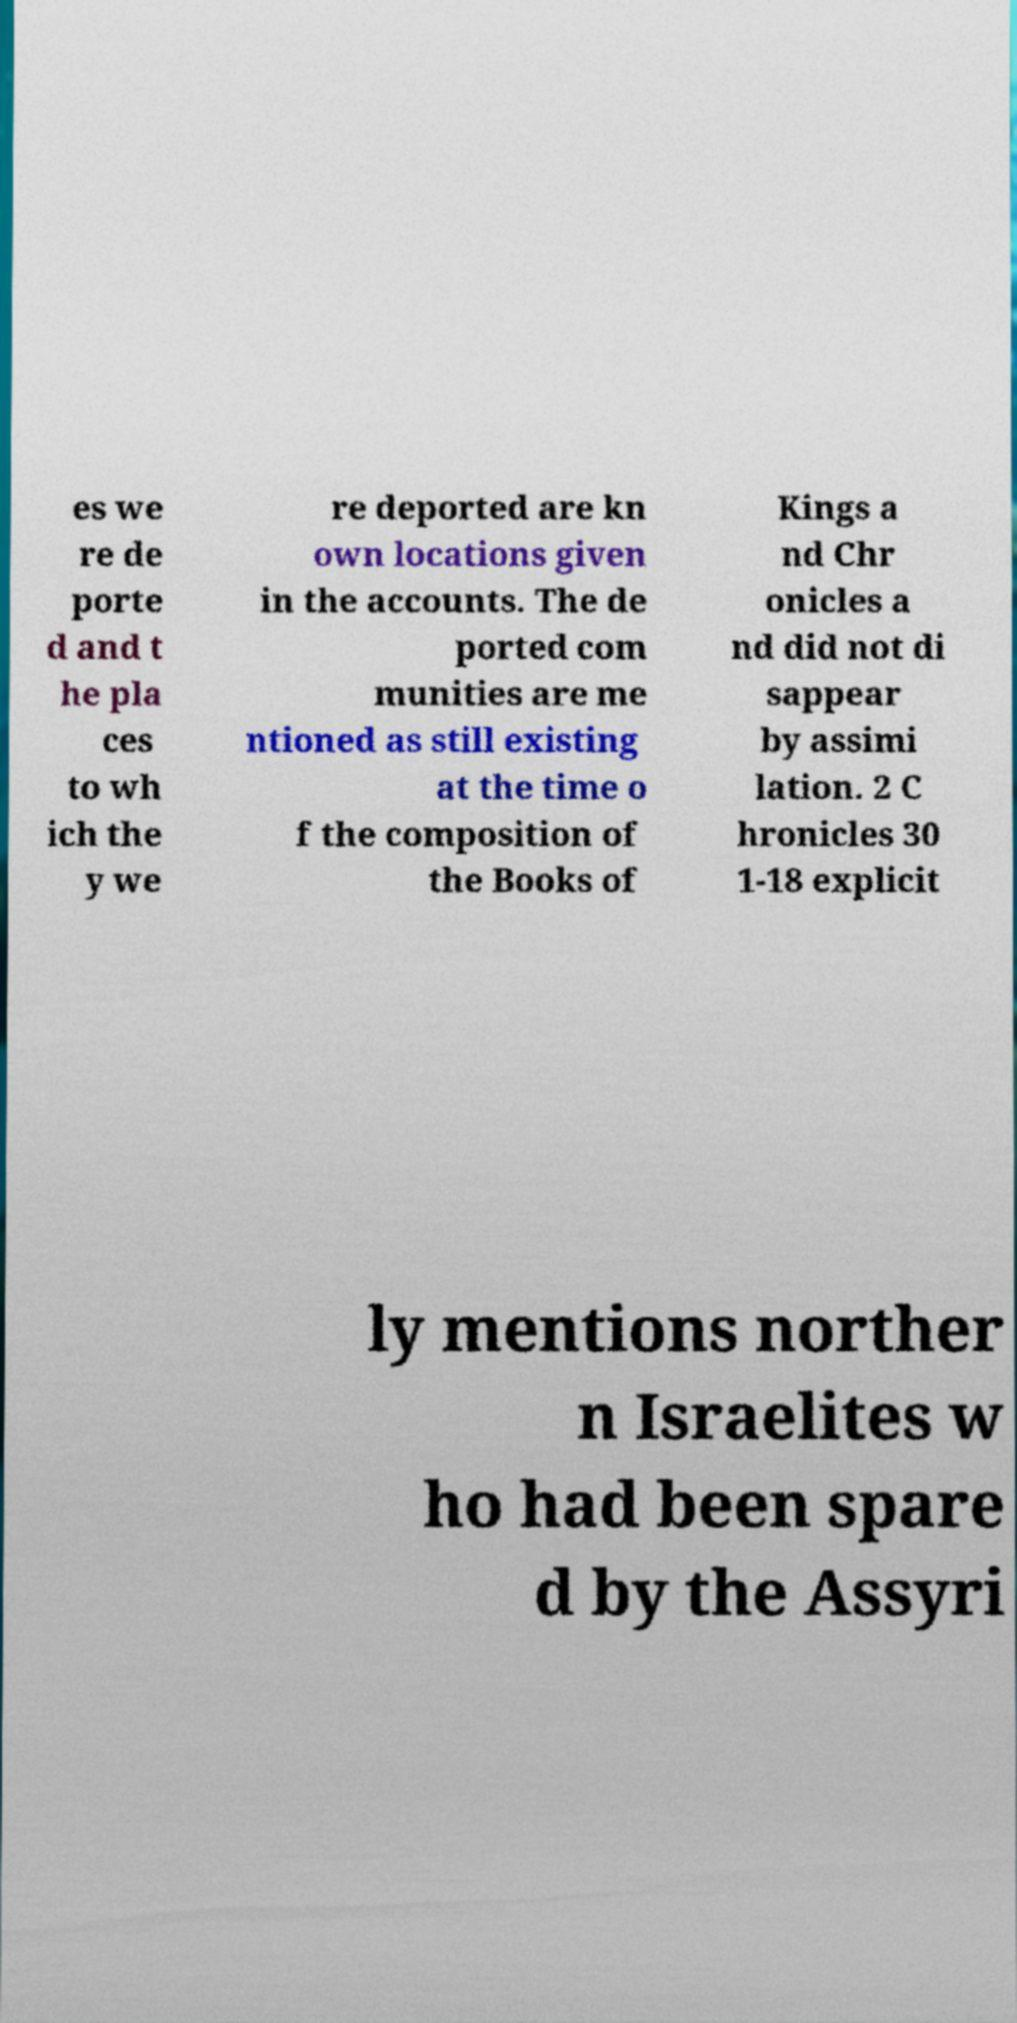There's text embedded in this image that I need extracted. Can you transcribe it verbatim? es we re de porte d and t he pla ces to wh ich the y we re deported are kn own locations given in the accounts. The de ported com munities are me ntioned as still existing at the time o f the composition of the Books of Kings a nd Chr onicles a nd did not di sappear by assimi lation. 2 C hronicles 30 1-18 explicit ly mentions norther n Israelites w ho had been spare d by the Assyri 